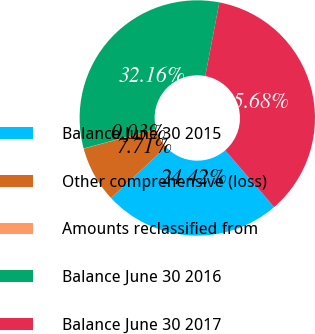Convert chart to OTSL. <chart><loc_0><loc_0><loc_500><loc_500><pie_chart><fcel>Balance June 30 2015<fcel>Other comprehensive (loss)<fcel>Amounts reclassified from<fcel>Balance June 30 2016<fcel>Balance June 30 2017<nl><fcel>24.42%<fcel>7.71%<fcel>0.03%<fcel>32.16%<fcel>35.68%<nl></chart> 